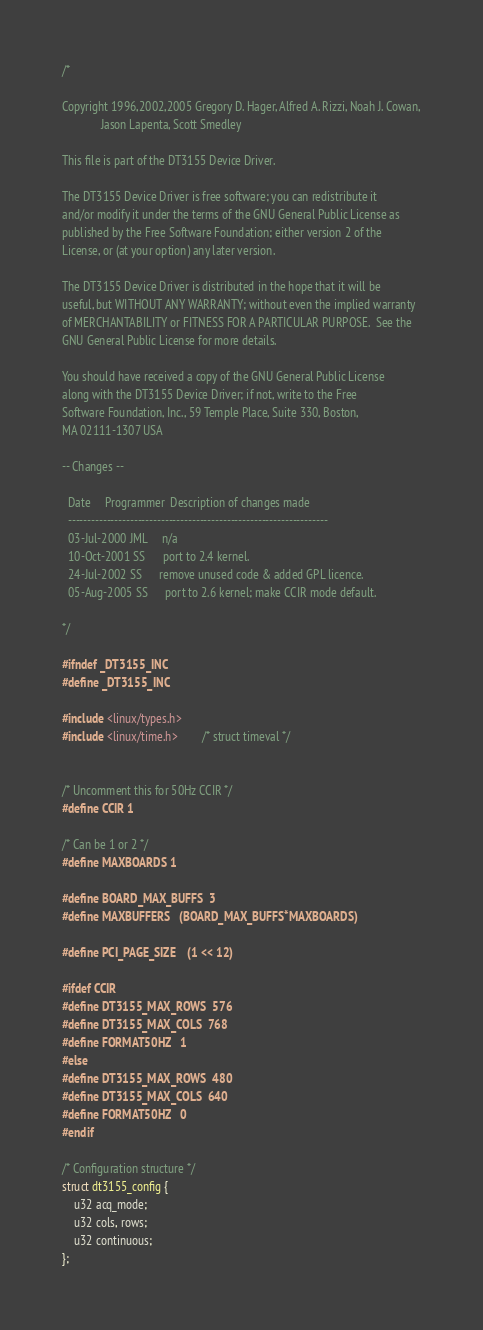Convert code to text. <code><loc_0><loc_0><loc_500><loc_500><_C_>/*

Copyright 1996,2002,2005 Gregory D. Hager, Alfred A. Rizzi, Noah J. Cowan,
			 Jason Lapenta, Scott Smedley

This file is part of the DT3155 Device Driver.

The DT3155 Device Driver is free software; you can redistribute it
and/or modify it under the terms of the GNU General Public License as
published by the Free Software Foundation; either version 2 of the
License, or (at your option) any later version.

The DT3155 Device Driver is distributed in the hope that it will be
useful, but WITHOUT ANY WARRANTY; without even the implied warranty
of MERCHANTABILITY or FITNESS FOR A PARTICULAR PURPOSE.  See the
GNU General Public License for more details.

You should have received a copy of the GNU General Public License
along with the DT3155 Device Driver; if not, write to the Free
Software Foundation, Inc., 59 Temple Place, Suite 330, Boston,
MA 02111-1307 USA

-- Changes --

  Date     Programmer  Description of changes made
  -------------------------------------------------------------------
  03-Jul-2000 JML     n/a
  10-Oct-2001 SS      port to 2.4 kernel.
  24-Jul-2002 SS      remove unused code & added GPL licence.
  05-Aug-2005 SS      port to 2.6 kernel; make CCIR mode default.

*/

#ifndef _DT3155_INC
#define _DT3155_INC

#include <linux/types.h>
#include <linux/time.h>		/* struct timeval */


/* Uncomment this for 50Hz CCIR */
#define CCIR 1

/* Can be 1 or 2 */
#define MAXBOARDS 1

#define BOARD_MAX_BUFFS	3
#define MAXBUFFERS	(BOARD_MAX_BUFFS*MAXBOARDS)

#define PCI_PAGE_SIZE	(1 << 12)

#ifdef CCIR
#define DT3155_MAX_ROWS	576
#define DT3155_MAX_COLS	768
#define FORMAT50HZ	1
#else
#define DT3155_MAX_ROWS	480
#define DT3155_MAX_COLS	640
#define FORMAT50HZ	0
#endif

/* Configuration structure */
struct dt3155_config {
	u32 acq_mode;
	u32 cols, rows;
	u32 continuous;
};

</code> 